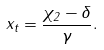Convert formula to latex. <formula><loc_0><loc_0><loc_500><loc_500>x _ { t } = \frac { \chi _ { 2 } - \delta } { \gamma } .</formula> 